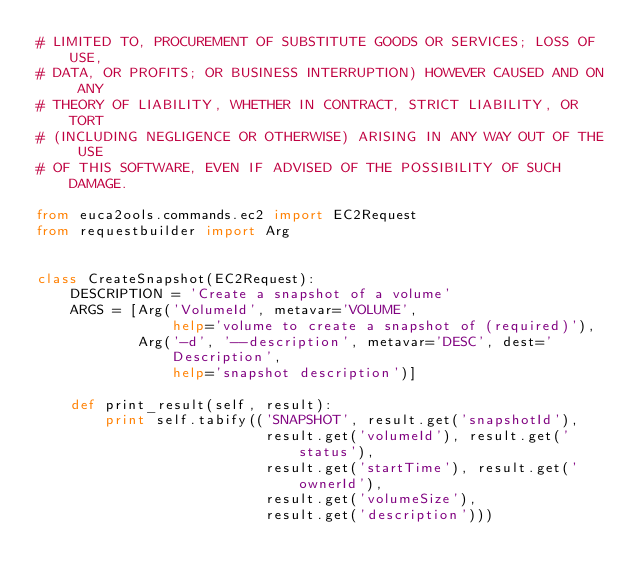Convert code to text. <code><loc_0><loc_0><loc_500><loc_500><_Python_># LIMITED TO, PROCUREMENT OF SUBSTITUTE GOODS OR SERVICES; LOSS OF USE,
# DATA, OR PROFITS; OR BUSINESS INTERRUPTION) HOWEVER CAUSED AND ON ANY
# THEORY OF LIABILITY, WHETHER IN CONTRACT, STRICT LIABILITY, OR TORT
# (INCLUDING NEGLIGENCE OR OTHERWISE) ARISING IN ANY WAY OUT OF THE USE
# OF THIS SOFTWARE, EVEN IF ADVISED OF THE POSSIBILITY OF SUCH DAMAGE.

from euca2ools.commands.ec2 import EC2Request
from requestbuilder import Arg


class CreateSnapshot(EC2Request):
    DESCRIPTION = 'Create a snapshot of a volume'
    ARGS = [Arg('VolumeId', metavar='VOLUME',
                help='volume to create a snapshot of (required)'),
            Arg('-d', '--description', metavar='DESC', dest='Description',
                help='snapshot description')]

    def print_result(self, result):
        print self.tabify(('SNAPSHOT', result.get('snapshotId'),
                           result.get('volumeId'), result.get('status'),
                           result.get('startTime'), result.get('ownerId'),
                           result.get('volumeSize'),
                           result.get('description')))
</code> 